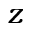Convert formula to latex. <formula><loc_0><loc_0><loc_500><loc_500>z</formula> 